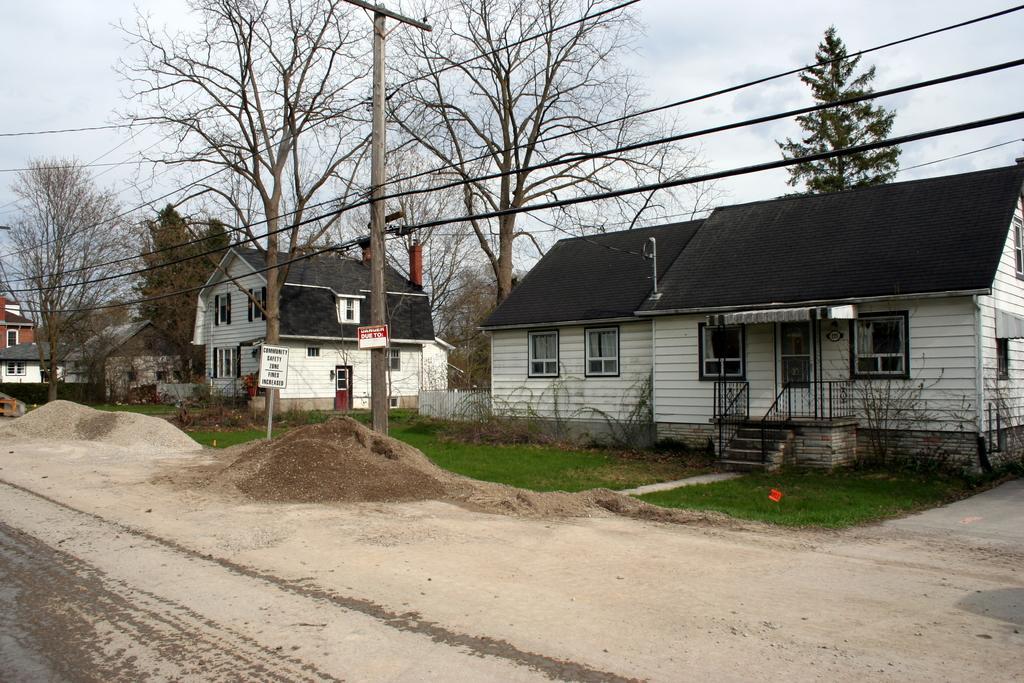Please provide a concise description of this image. In this image, there are a few houses, poles, trees, wires, boards with text. We can see the ground with some objects. We can also see some grass and plants. We can see the sky. We can see some stairs and the railing. 